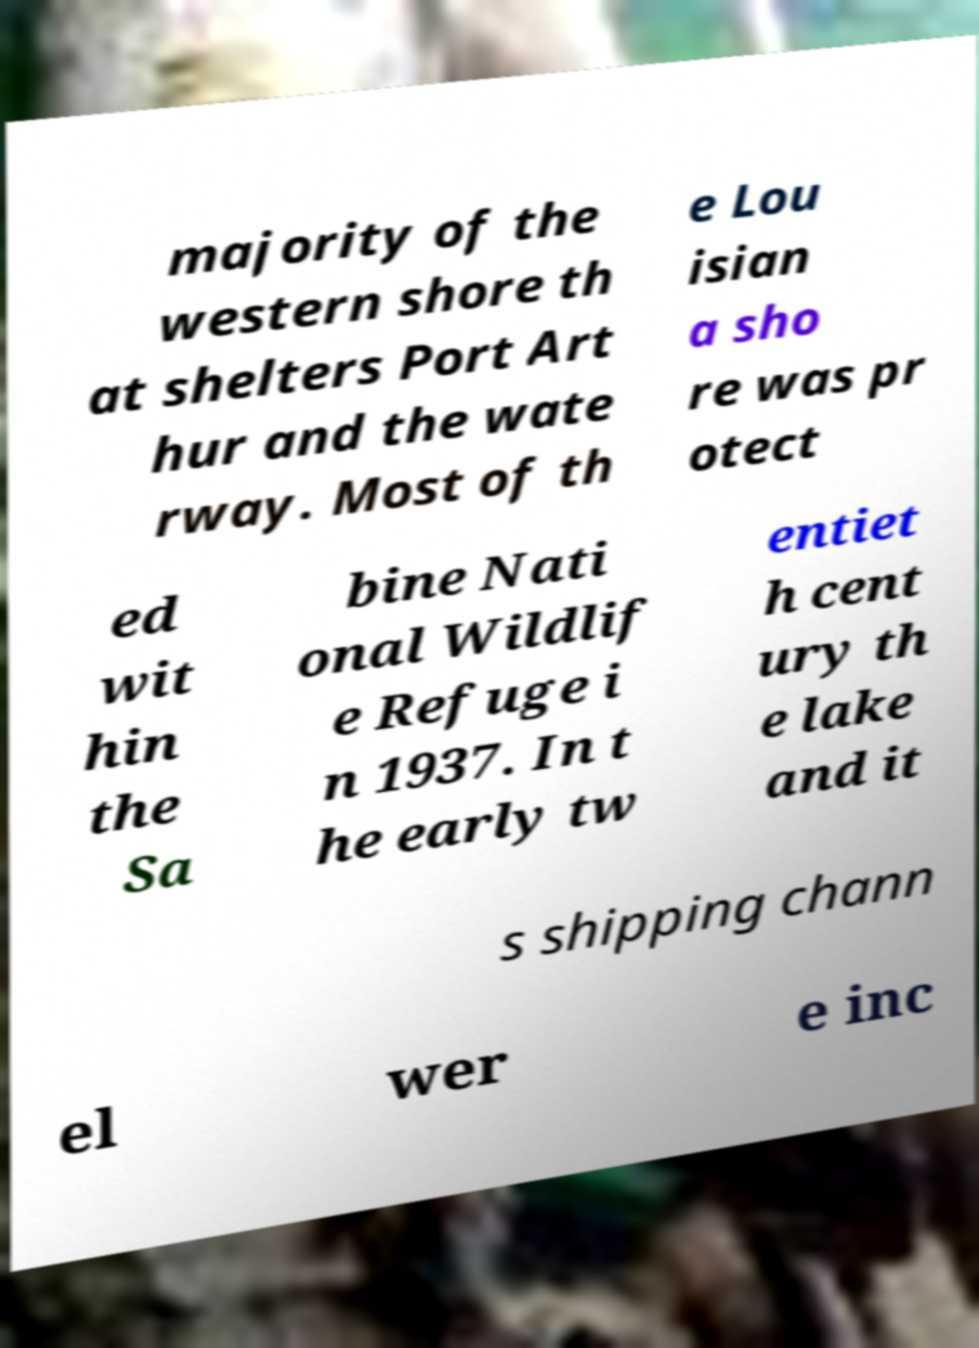For documentation purposes, I need the text within this image transcribed. Could you provide that? majority of the western shore th at shelters Port Art hur and the wate rway. Most of th e Lou isian a sho re was pr otect ed wit hin the Sa bine Nati onal Wildlif e Refuge i n 1937. In t he early tw entiet h cent ury th e lake and it s shipping chann el wer e inc 